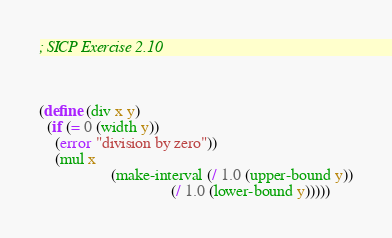Convert code to text. <code><loc_0><loc_0><loc_500><loc_500><_Scheme_>; SICP Exercise 2.10



(define (div x y)
  (if (= 0 (width y))
    (error "division by zero"))
    (mul x
                  (make-interval (/ 1.0 (upper-bound y))
                                 (/ 1.0 (lower-bound y)))))
</code> 